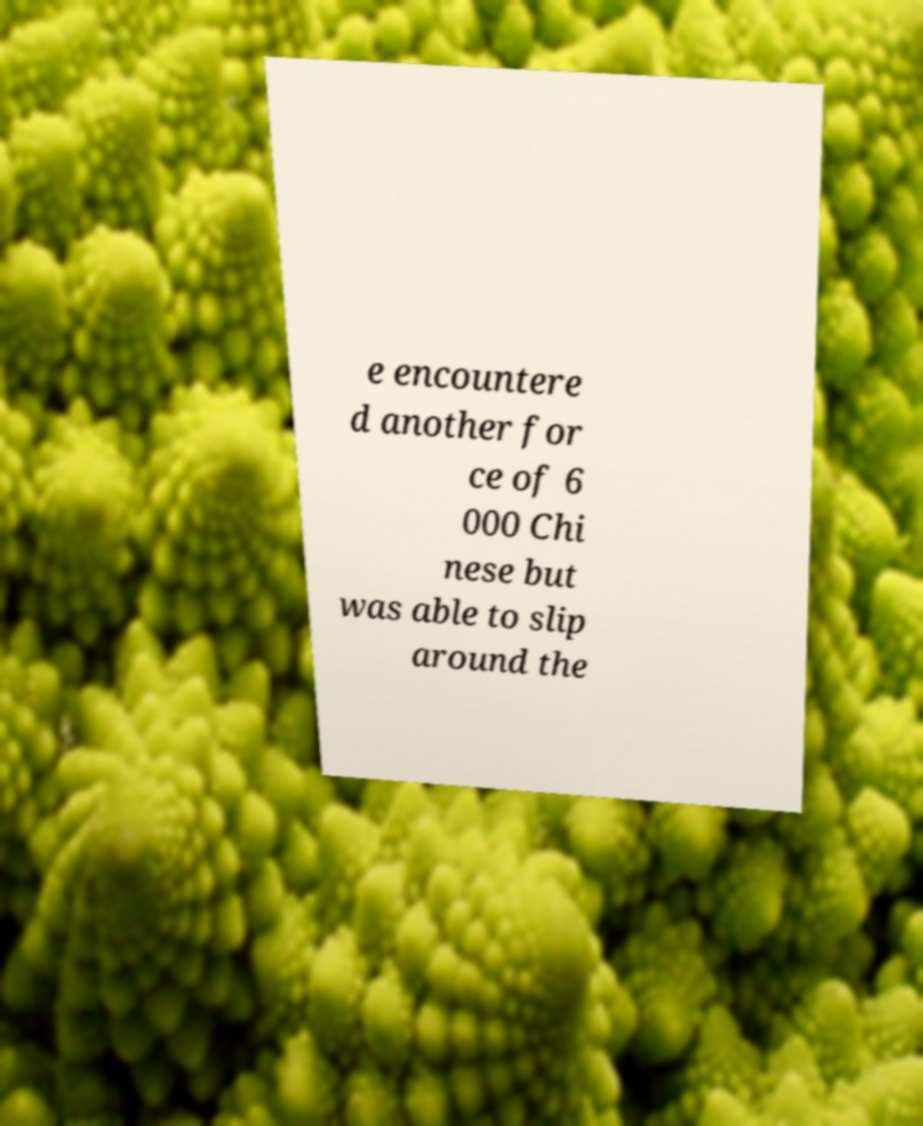I need the written content from this picture converted into text. Can you do that? e encountere d another for ce of 6 000 Chi nese but was able to slip around the 